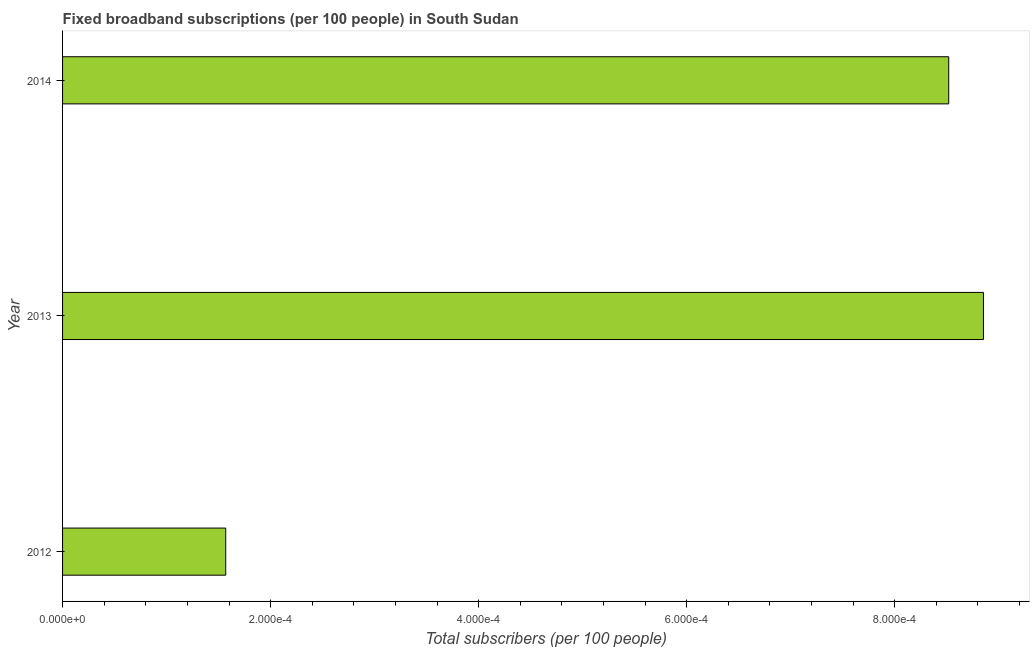Does the graph contain grids?
Keep it short and to the point. No. What is the title of the graph?
Provide a short and direct response. Fixed broadband subscriptions (per 100 people) in South Sudan. What is the label or title of the X-axis?
Ensure brevity in your answer.  Total subscribers (per 100 people). What is the total number of fixed broadband subscriptions in 2014?
Your answer should be very brief. 0. Across all years, what is the maximum total number of fixed broadband subscriptions?
Offer a terse response. 0. Across all years, what is the minimum total number of fixed broadband subscriptions?
Keep it short and to the point. 0. In which year was the total number of fixed broadband subscriptions maximum?
Make the answer very short. 2013. In which year was the total number of fixed broadband subscriptions minimum?
Keep it short and to the point. 2012. What is the sum of the total number of fixed broadband subscriptions?
Your response must be concise. 0. What is the difference between the total number of fixed broadband subscriptions in 2012 and 2014?
Provide a succinct answer. -0. What is the median total number of fixed broadband subscriptions?
Provide a succinct answer. 0. Do a majority of the years between 2014 and 2013 (inclusive) have total number of fixed broadband subscriptions greater than 0.00012 ?
Offer a very short reply. No. What is the ratio of the total number of fixed broadband subscriptions in 2012 to that in 2014?
Your answer should be compact. 0.18. Is the difference between the total number of fixed broadband subscriptions in 2013 and 2014 greater than the difference between any two years?
Provide a succinct answer. No. Is the sum of the total number of fixed broadband subscriptions in 2013 and 2014 greater than the maximum total number of fixed broadband subscriptions across all years?
Provide a succinct answer. Yes. What is the difference between the highest and the lowest total number of fixed broadband subscriptions?
Ensure brevity in your answer.  0. Are all the bars in the graph horizontal?
Make the answer very short. Yes. Are the values on the major ticks of X-axis written in scientific E-notation?
Provide a succinct answer. Yes. What is the Total subscribers (per 100 people) in 2012?
Provide a short and direct response. 0. What is the Total subscribers (per 100 people) in 2013?
Your answer should be compact. 0. What is the Total subscribers (per 100 people) of 2014?
Provide a short and direct response. 0. What is the difference between the Total subscribers (per 100 people) in 2012 and 2013?
Your answer should be very brief. -0. What is the difference between the Total subscribers (per 100 people) in 2012 and 2014?
Your response must be concise. -0. What is the difference between the Total subscribers (per 100 people) in 2013 and 2014?
Provide a succinct answer. 3e-5. What is the ratio of the Total subscribers (per 100 people) in 2012 to that in 2013?
Give a very brief answer. 0.18. What is the ratio of the Total subscribers (per 100 people) in 2012 to that in 2014?
Your answer should be compact. 0.18. What is the ratio of the Total subscribers (per 100 people) in 2013 to that in 2014?
Provide a succinct answer. 1.04. 